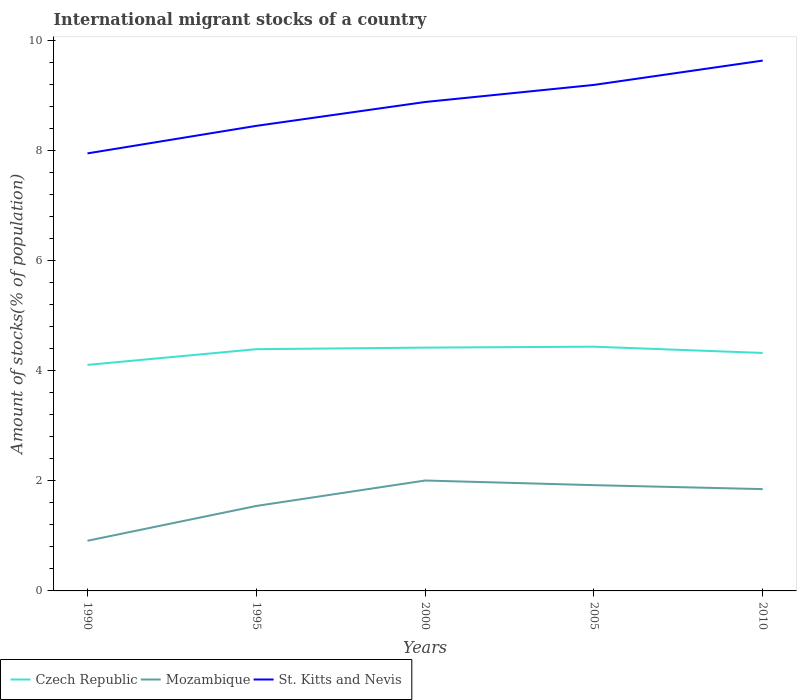How many different coloured lines are there?
Your response must be concise. 3. Is the number of lines equal to the number of legend labels?
Give a very brief answer. Yes. Across all years, what is the maximum amount of stocks in in Mozambique?
Keep it short and to the point. 0.91. In which year was the amount of stocks in in Czech Republic maximum?
Ensure brevity in your answer.  1990. What is the total amount of stocks in in Czech Republic in the graph?
Give a very brief answer. -0.03. What is the difference between the highest and the second highest amount of stocks in in St. Kitts and Nevis?
Provide a short and direct response. 1.69. Is the amount of stocks in in Czech Republic strictly greater than the amount of stocks in in Mozambique over the years?
Your response must be concise. No. How many lines are there?
Provide a short and direct response. 3. What is the difference between two consecutive major ticks on the Y-axis?
Offer a very short reply. 2. Does the graph contain any zero values?
Your answer should be very brief. No. Does the graph contain grids?
Make the answer very short. No. How are the legend labels stacked?
Make the answer very short. Horizontal. What is the title of the graph?
Provide a short and direct response. International migrant stocks of a country. Does "Tonga" appear as one of the legend labels in the graph?
Your answer should be compact. No. What is the label or title of the X-axis?
Your answer should be very brief. Years. What is the label or title of the Y-axis?
Ensure brevity in your answer.  Amount of stocks(% of population). What is the Amount of stocks(% of population) of Czech Republic in 1990?
Make the answer very short. 4.11. What is the Amount of stocks(% of population) in Mozambique in 1990?
Your answer should be very brief. 0.91. What is the Amount of stocks(% of population) of St. Kitts and Nevis in 1990?
Keep it short and to the point. 7.95. What is the Amount of stocks(% of population) in Czech Republic in 1995?
Your answer should be very brief. 4.39. What is the Amount of stocks(% of population) of Mozambique in 1995?
Offer a very short reply. 1.54. What is the Amount of stocks(% of population) in St. Kitts and Nevis in 1995?
Give a very brief answer. 8.45. What is the Amount of stocks(% of population) in Czech Republic in 2000?
Your response must be concise. 4.42. What is the Amount of stocks(% of population) of Mozambique in 2000?
Keep it short and to the point. 2.01. What is the Amount of stocks(% of population) in St. Kitts and Nevis in 2000?
Your response must be concise. 8.89. What is the Amount of stocks(% of population) in Czech Republic in 2005?
Provide a succinct answer. 4.44. What is the Amount of stocks(% of population) of Mozambique in 2005?
Make the answer very short. 1.92. What is the Amount of stocks(% of population) of St. Kitts and Nevis in 2005?
Ensure brevity in your answer.  9.2. What is the Amount of stocks(% of population) in Czech Republic in 2010?
Provide a short and direct response. 4.33. What is the Amount of stocks(% of population) of Mozambique in 2010?
Provide a succinct answer. 1.85. What is the Amount of stocks(% of population) of St. Kitts and Nevis in 2010?
Provide a succinct answer. 9.64. Across all years, what is the maximum Amount of stocks(% of population) in Czech Republic?
Provide a succinct answer. 4.44. Across all years, what is the maximum Amount of stocks(% of population) in Mozambique?
Give a very brief answer. 2.01. Across all years, what is the maximum Amount of stocks(% of population) of St. Kitts and Nevis?
Ensure brevity in your answer.  9.64. Across all years, what is the minimum Amount of stocks(% of population) in Czech Republic?
Your response must be concise. 4.11. Across all years, what is the minimum Amount of stocks(% of population) in Mozambique?
Your answer should be compact. 0.91. Across all years, what is the minimum Amount of stocks(% of population) in St. Kitts and Nevis?
Make the answer very short. 7.95. What is the total Amount of stocks(% of population) of Czech Republic in the graph?
Make the answer very short. 21.69. What is the total Amount of stocks(% of population) in Mozambique in the graph?
Provide a short and direct response. 8.23. What is the total Amount of stocks(% of population) in St. Kitts and Nevis in the graph?
Give a very brief answer. 44.12. What is the difference between the Amount of stocks(% of population) of Czech Republic in 1990 and that in 1995?
Ensure brevity in your answer.  -0.29. What is the difference between the Amount of stocks(% of population) of Mozambique in 1990 and that in 1995?
Offer a very short reply. -0.63. What is the difference between the Amount of stocks(% of population) of St. Kitts and Nevis in 1990 and that in 1995?
Provide a short and direct response. -0.5. What is the difference between the Amount of stocks(% of population) in Czech Republic in 1990 and that in 2000?
Give a very brief answer. -0.31. What is the difference between the Amount of stocks(% of population) of Mozambique in 1990 and that in 2000?
Your response must be concise. -1.09. What is the difference between the Amount of stocks(% of population) of St. Kitts and Nevis in 1990 and that in 2000?
Give a very brief answer. -0.93. What is the difference between the Amount of stocks(% of population) in Czech Republic in 1990 and that in 2005?
Keep it short and to the point. -0.33. What is the difference between the Amount of stocks(% of population) in Mozambique in 1990 and that in 2005?
Give a very brief answer. -1.01. What is the difference between the Amount of stocks(% of population) of St. Kitts and Nevis in 1990 and that in 2005?
Offer a very short reply. -1.24. What is the difference between the Amount of stocks(% of population) of Czech Republic in 1990 and that in 2010?
Give a very brief answer. -0.22. What is the difference between the Amount of stocks(% of population) in Mozambique in 1990 and that in 2010?
Provide a succinct answer. -0.94. What is the difference between the Amount of stocks(% of population) in St. Kitts and Nevis in 1990 and that in 2010?
Your response must be concise. -1.69. What is the difference between the Amount of stocks(% of population) of Czech Republic in 1995 and that in 2000?
Offer a terse response. -0.03. What is the difference between the Amount of stocks(% of population) of Mozambique in 1995 and that in 2000?
Make the answer very short. -0.46. What is the difference between the Amount of stocks(% of population) of St. Kitts and Nevis in 1995 and that in 2000?
Your answer should be compact. -0.43. What is the difference between the Amount of stocks(% of population) in Czech Republic in 1995 and that in 2005?
Make the answer very short. -0.05. What is the difference between the Amount of stocks(% of population) of Mozambique in 1995 and that in 2005?
Make the answer very short. -0.38. What is the difference between the Amount of stocks(% of population) in St. Kitts and Nevis in 1995 and that in 2005?
Give a very brief answer. -0.74. What is the difference between the Amount of stocks(% of population) of Czech Republic in 1995 and that in 2010?
Your answer should be very brief. 0.07. What is the difference between the Amount of stocks(% of population) in Mozambique in 1995 and that in 2010?
Provide a succinct answer. -0.31. What is the difference between the Amount of stocks(% of population) in St. Kitts and Nevis in 1995 and that in 2010?
Offer a terse response. -1.19. What is the difference between the Amount of stocks(% of population) of Czech Republic in 2000 and that in 2005?
Keep it short and to the point. -0.02. What is the difference between the Amount of stocks(% of population) in Mozambique in 2000 and that in 2005?
Make the answer very short. 0.08. What is the difference between the Amount of stocks(% of population) of St. Kitts and Nevis in 2000 and that in 2005?
Provide a short and direct response. -0.31. What is the difference between the Amount of stocks(% of population) of Czech Republic in 2000 and that in 2010?
Provide a short and direct response. 0.1. What is the difference between the Amount of stocks(% of population) in Mozambique in 2000 and that in 2010?
Give a very brief answer. 0.16. What is the difference between the Amount of stocks(% of population) in St. Kitts and Nevis in 2000 and that in 2010?
Offer a very short reply. -0.75. What is the difference between the Amount of stocks(% of population) in Czech Republic in 2005 and that in 2010?
Offer a very short reply. 0.11. What is the difference between the Amount of stocks(% of population) of Mozambique in 2005 and that in 2010?
Provide a short and direct response. 0.07. What is the difference between the Amount of stocks(% of population) in St. Kitts and Nevis in 2005 and that in 2010?
Offer a terse response. -0.44. What is the difference between the Amount of stocks(% of population) in Czech Republic in 1990 and the Amount of stocks(% of population) in Mozambique in 1995?
Give a very brief answer. 2.56. What is the difference between the Amount of stocks(% of population) in Czech Republic in 1990 and the Amount of stocks(% of population) in St. Kitts and Nevis in 1995?
Your response must be concise. -4.34. What is the difference between the Amount of stocks(% of population) in Mozambique in 1990 and the Amount of stocks(% of population) in St. Kitts and Nevis in 1995?
Give a very brief answer. -7.54. What is the difference between the Amount of stocks(% of population) in Czech Republic in 1990 and the Amount of stocks(% of population) in Mozambique in 2000?
Make the answer very short. 2.1. What is the difference between the Amount of stocks(% of population) in Czech Republic in 1990 and the Amount of stocks(% of population) in St. Kitts and Nevis in 2000?
Provide a succinct answer. -4.78. What is the difference between the Amount of stocks(% of population) of Mozambique in 1990 and the Amount of stocks(% of population) of St. Kitts and Nevis in 2000?
Offer a terse response. -7.97. What is the difference between the Amount of stocks(% of population) of Czech Republic in 1990 and the Amount of stocks(% of population) of Mozambique in 2005?
Offer a very short reply. 2.19. What is the difference between the Amount of stocks(% of population) in Czech Republic in 1990 and the Amount of stocks(% of population) in St. Kitts and Nevis in 2005?
Offer a very short reply. -5.09. What is the difference between the Amount of stocks(% of population) in Mozambique in 1990 and the Amount of stocks(% of population) in St. Kitts and Nevis in 2005?
Offer a terse response. -8.28. What is the difference between the Amount of stocks(% of population) in Czech Republic in 1990 and the Amount of stocks(% of population) in Mozambique in 2010?
Give a very brief answer. 2.26. What is the difference between the Amount of stocks(% of population) in Czech Republic in 1990 and the Amount of stocks(% of population) in St. Kitts and Nevis in 2010?
Your answer should be very brief. -5.53. What is the difference between the Amount of stocks(% of population) in Mozambique in 1990 and the Amount of stocks(% of population) in St. Kitts and Nevis in 2010?
Offer a very short reply. -8.73. What is the difference between the Amount of stocks(% of population) in Czech Republic in 1995 and the Amount of stocks(% of population) in Mozambique in 2000?
Provide a succinct answer. 2.39. What is the difference between the Amount of stocks(% of population) of Czech Republic in 1995 and the Amount of stocks(% of population) of St. Kitts and Nevis in 2000?
Offer a terse response. -4.49. What is the difference between the Amount of stocks(% of population) of Mozambique in 1995 and the Amount of stocks(% of population) of St. Kitts and Nevis in 2000?
Ensure brevity in your answer.  -7.34. What is the difference between the Amount of stocks(% of population) of Czech Republic in 1995 and the Amount of stocks(% of population) of Mozambique in 2005?
Provide a short and direct response. 2.47. What is the difference between the Amount of stocks(% of population) in Czech Republic in 1995 and the Amount of stocks(% of population) in St. Kitts and Nevis in 2005?
Provide a succinct answer. -4.8. What is the difference between the Amount of stocks(% of population) in Mozambique in 1995 and the Amount of stocks(% of population) in St. Kitts and Nevis in 2005?
Keep it short and to the point. -7.65. What is the difference between the Amount of stocks(% of population) in Czech Republic in 1995 and the Amount of stocks(% of population) in Mozambique in 2010?
Make the answer very short. 2.54. What is the difference between the Amount of stocks(% of population) in Czech Republic in 1995 and the Amount of stocks(% of population) in St. Kitts and Nevis in 2010?
Keep it short and to the point. -5.25. What is the difference between the Amount of stocks(% of population) in Mozambique in 1995 and the Amount of stocks(% of population) in St. Kitts and Nevis in 2010?
Your answer should be compact. -8.09. What is the difference between the Amount of stocks(% of population) in Czech Republic in 2000 and the Amount of stocks(% of population) in St. Kitts and Nevis in 2005?
Give a very brief answer. -4.77. What is the difference between the Amount of stocks(% of population) of Mozambique in 2000 and the Amount of stocks(% of population) of St. Kitts and Nevis in 2005?
Ensure brevity in your answer.  -7.19. What is the difference between the Amount of stocks(% of population) of Czech Republic in 2000 and the Amount of stocks(% of population) of Mozambique in 2010?
Offer a terse response. 2.57. What is the difference between the Amount of stocks(% of population) in Czech Republic in 2000 and the Amount of stocks(% of population) in St. Kitts and Nevis in 2010?
Keep it short and to the point. -5.22. What is the difference between the Amount of stocks(% of population) of Mozambique in 2000 and the Amount of stocks(% of population) of St. Kitts and Nevis in 2010?
Provide a short and direct response. -7.63. What is the difference between the Amount of stocks(% of population) of Czech Republic in 2005 and the Amount of stocks(% of population) of Mozambique in 2010?
Offer a very short reply. 2.59. What is the difference between the Amount of stocks(% of population) of Czech Republic in 2005 and the Amount of stocks(% of population) of St. Kitts and Nevis in 2010?
Make the answer very short. -5.2. What is the difference between the Amount of stocks(% of population) in Mozambique in 2005 and the Amount of stocks(% of population) in St. Kitts and Nevis in 2010?
Provide a short and direct response. -7.72. What is the average Amount of stocks(% of population) in Czech Republic per year?
Make the answer very short. 4.34. What is the average Amount of stocks(% of population) in Mozambique per year?
Offer a very short reply. 1.65. What is the average Amount of stocks(% of population) in St. Kitts and Nevis per year?
Keep it short and to the point. 8.82. In the year 1990, what is the difference between the Amount of stocks(% of population) in Czech Republic and Amount of stocks(% of population) in Mozambique?
Give a very brief answer. 3.2. In the year 1990, what is the difference between the Amount of stocks(% of population) of Czech Republic and Amount of stocks(% of population) of St. Kitts and Nevis?
Provide a succinct answer. -3.84. In the year 1990, what is the difference between the Amount of stocks(% of population) in Mozambique and Amount of stocks(% of population) in St. Kitts and Nevis?
Provide a short and direct response. -7.04. In the year 1995, what is the difference between the Amount of stocks(% of population) of Czech Republic and Amount of stocks(% of population) of Mozambique?
Ensure brevity in your answer.  2.85. In the year 1995, what is the difference between the Amount of stocks(% of population) in Czech Republic and Amount of stocks(% of population) in St. Kitts and Nevis?
Offer a very short reply. -4.06. In the year 1995, what is the difference between the Amount of stocks(% of population) of Mozambique and Amount of stocks(% of population) of St. Kitts and Nevis?
Make the answer very short. -6.91. In the year 2000, what is the difference between the Amount of stocks(% of population) in Czech Republic and Amount of stocks(% of population) in Mozambique?
Give a very brief answer. 2.42. In the year 2000, what is the difference between the Amount of stocks(% of population) of Czech Republic and Amount of stocks(% of population) of St. Kitts and Nevis?
Offer a terse response. -4.46. In the year 2000, what is the difference between the Amount of stocks(% of population) of Mozambique and Amount of stocks(% of population) of St. Kitts and Nevis?
Provide a succinct answer. -6.88. In the year 2005, what is the difference between the Amount of stocks(% of population) in Czech Republic and Amount of stocks(% of population) in Mozambique?
Make the answer very short. 2.52. In the year 2005, what is the difference between the Amount of stocks(% of population) of Czech Republic and Amount of stocks(% of population) of St. Kitts and Nevis?
Ensure brevity in your answer.  -4.76. In the year 2005, what is the difference between the Amount of stocks(% of population) of Mozambique and Amount of stocks(% of population) of St. Kitts and Nevis?
Provide a succinct answer. -7.27. In the year 2010, what is the difference between the Amount of stocks(% of population) of Czech Republic and Amount of stocks(% of population) of Mozambique?
Keep it short and to the point. 2.47. In the year 2010, what is the difference between the Amount of stocks(% of population) of Czech Republic and Amount of stocks(% of population) of St. Kitts and Nevis?
Give a very brief answer. -5.31. In the year 2010, what is the difference between the Amount of stocks(% of population) of Mozambique and Amount of stocks(% of population) of St. Kitts and Nevis?
Offer a terse response. -7.79. What is the ratio of the Amount of stocks(% of population) in Czech Republic in 1990 to that in 1995?
Keep it short and to the point. 0.94. What is the ratio of the Amount of stocks(% of population) of Mozambique in 1990 to that in 1995?
Offer a terse response. 0.59. What is the ratio of the Amount of stocks(% of population) of St. Kitts and Nevis in 1990 to that in 1995?
Keep it short and to the point. 0.94. What is the ratio of the Amount of stocks(% of population) of Czech Republic in 1990 to that in 2000?
Your answer should be very brief. 0.93. What is the ratio of the Amount of stocks(% of population) of Mozambique in 1990 to that in 2000?
Provide a succinct answer. 0.45. What is the ratio of the Amount of stocks(% of population) in St. Kitts and Nevis in 1990 to that in 2000?
Keep it short and to the point. 0.89. What is the ratio of the Amount of stocks(% of population) in Czech Republic in 1990 to that in 2005?
Provide a succinct answer. 0.93. What is the ratio of the Amount of stocks(% of population) of Mozambique in 1990 to that in 2005?
Your answer should be very brief. 0.47. What is the ratio of the Amount of stocks(% of population) in St. Kitts and Nevis in 1990 to that in 2005?
Give a very brief answer. 0.86. What is the ratio of the Amount of stocks(% of population) of Czech Republic in 1990 to that in 2010?
Give a very brief answer. 0.95. What is the ratio of the Amount of stocks(% of population) of Mozambique in 1990 to that in 2010?
Your answer should be compact. 0.49. What is the ratio of the Amount of stocks(% of population) of St. Kitts and Nevis in 1990 to that in 2010?
Provide a succinct answer. 0.82. What is the ratio of the Amount of stocks(% of population) of Czech Republic in 1995 to that in 2000?
Keep it short and to the point. 0.99. What is the ratio of the Amount of stocks(% of population) in Mozambique in 1995 to that in 2000?
Ensure brevity in your answer.  0.77. What is the ratio of the Amount of stocks(% of population) in St. Kitts and Nevis in 1995 to that in 2000?
Make the answer very short. 0.95. What is the ratio of the Amount of stocks(% of population) in Czech Republic in 1995 to that in 2005?
Provide a succinct answer. 0.99. What is the ratio of the Amount of stocks(% of population) in Mozambique in 1995 to that in 2005?
Ensure brevity in your answer.  0.8. What is the ratio of the Amount of stocks(% of population) of St. Kitts and Nevis in 1995 to that in 2005?
Make the answer very short. 0.92. What is the ratio of the Amount of stocks(% of population) in Czech Republic in 1995 to that in 2010?
Ensure brevity in your answer.  1.02. What is the ratio of the Amount of stocks(% of population) in Mozambique in 1995 to that in 2010?
Provide a short and direct response. 0.83. What is the ratio of the Amount of stocks(% of population) of St. Kitts and Nevis in 1995 to that in 2010?
Your answer should be compact. 0.88. What is the ratio of the Amount of stocks(% of population) in Mozambique in 2000 to that in 2005?
Your response must be concise. 1.04. What is the ratio of the Amount of stocks(% of population) in St. Kitts and Nevis in 2000 to that in 2005?
Offer a very short reply. 0.97. What is the ratio of the Amount of stocks(% of population) in Czech Republic in 2000 to that in 2010?
Your answer should be compact. 1.02. What is the ratio of the Amount of stocks(% of population) in Mozambique in 2000 to that in 2010?
Your answer should be compact. 1.08. What is the ratio of the Amount of stocks(% of population) in St. Kitts and Nevis in 2000 to that in 2010?
Your answer should be compact. 0.92. What is the ratio of the Amount of stocks(% of population) of Czech Republic in 2005 to that in 2010?
Offer a terse response. 1.03. What is the ratio of the Amount of stocks(% of population) in Mozambique in 2005 to that in 2010?
Make the answer very short. 1.04. What is the ratio of the Amount of stocks(% of population) in St. Kitts and Nevis in 2005 to that in 2010?
Give a very brief answer. 0.95. What is the difference between the highest and the second highest Amount of stocks(% of population) of Czech Republic?
Provide a succinct answer. 0.02. What is the difference between the highest and the second highest Amount of stocks(% of population) of Mozambique?
Your answer should be very brief. 0.08. What is the difference between the highest and the second highest Amount of stocks(% of population) of St. Kitts and Nevis?
Your response must be concise. 0.44. What is the difference between the highest and the lowest Amount of stocks(% of population) of Czech Republic?
Your answer should be compact. 0.33. What is the difference between the highest and the lowest Amount of stocks(% of population) of Mozambique?
Provide a short and direct response. 1.09. What is the difference between the highest and the lowest Amount of stocks(% of population) of St. Kitts and Nevis?
Offer a very short reply. 1.69. 